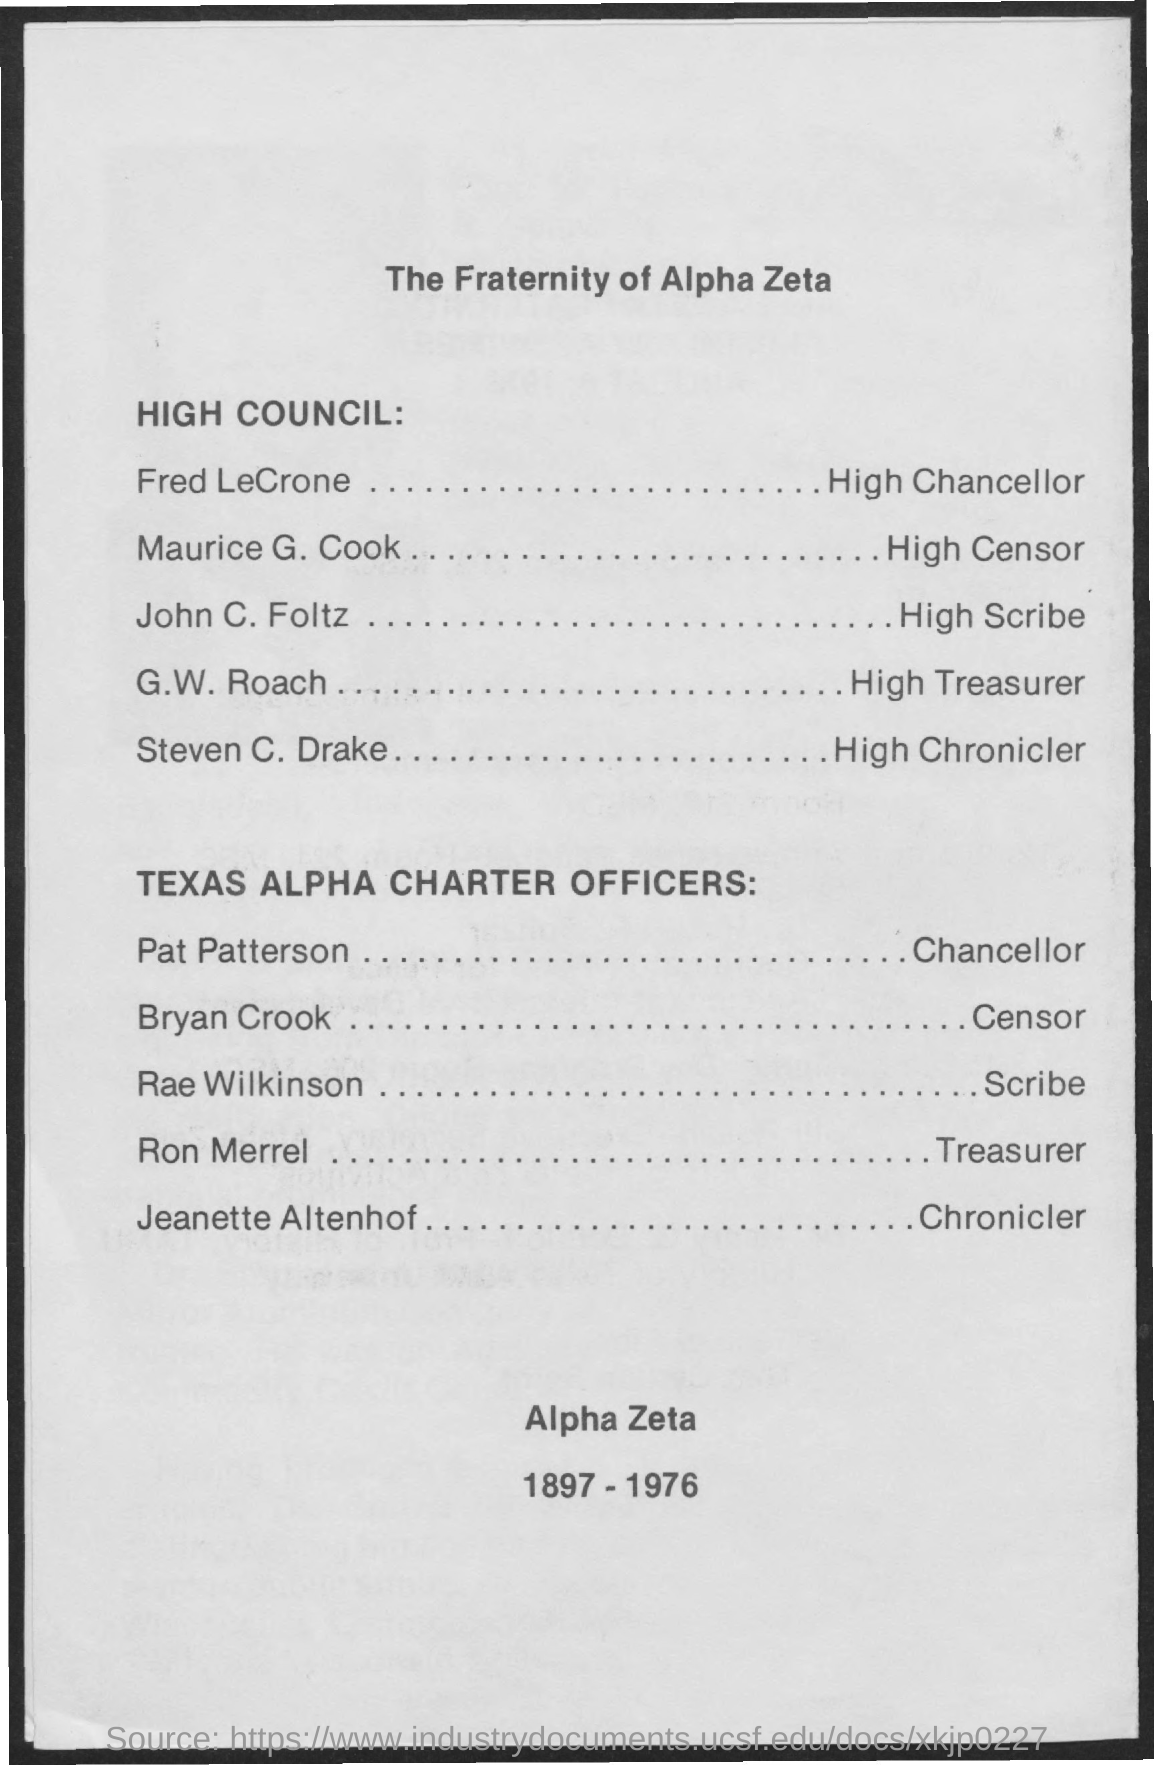Outline some significant characteristics in this image. The title of the document is 'What is the Title of the document? The Fraternity of Alpha Zeta..' The High Chancellor's name is Fred Lecrone. 